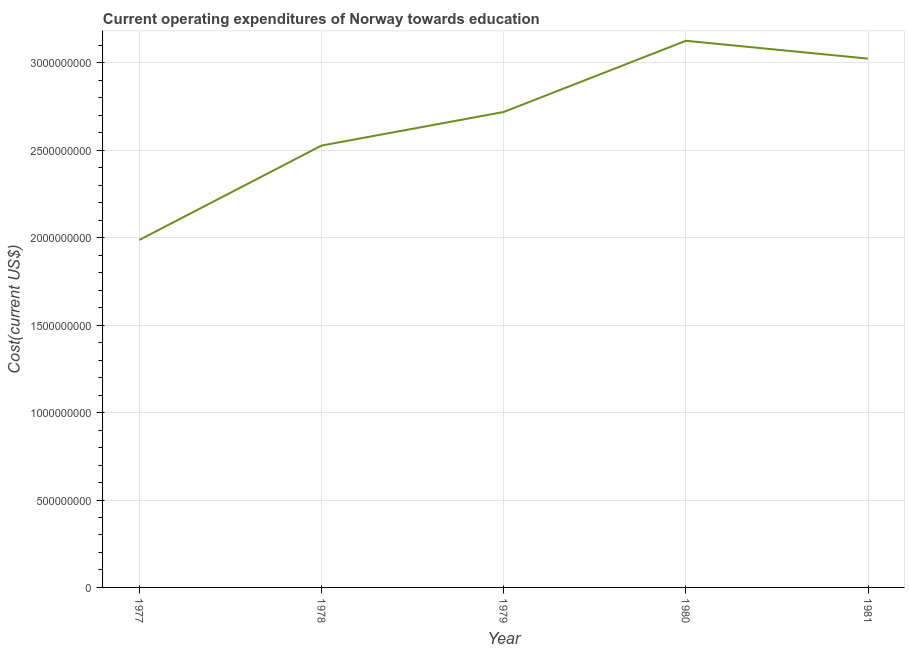What is the education expenditure in 1979?
Your response must be concise. 2.72e+09. Across all years, what is the maximum education expenditure?
Provide a short and direct response. 3.13e+09. Across all years, what is the minimum education expenditure?
Keep it short and to the point. 1.99e+09. In which year was the education expenditure minimum?
Give a very brief answer. 1977. What is the sum of the education expenditure?
Make the answer very short. 1.34e+1. What is the difference between the education expenditure in 1978 and 1979?
Ensure brevity in your answer.  -1.92e+08. What is the average education expenditure per year?
Make the answer very short. 2.68e+09. What is the median education expenditure?
Your answer should be compact. 2.72e+09. What is the ratio of the education expenditure in 1980 to that in 1981?
Provide a short and direct response. 1.03. Is the difference between the education expenditure in 1977 and 1981 greater than the difference between any two years?
Ensure brevity in your answer.  No. What is the difference between the highest and the second highest education expenditure?
Your answer should be very brief. 1.02e+08. What is the difference between the highest and the lowest education expenditure?
Offer a very short reply. 1.14e+09. In how many years, is the education expenditure greater than the average education expenditure taken over all years?
Provide a short and direct response. 3. What is the difference between two consecutive major ticks on the Y-axis?
Your answer should be compact. 5.00e+08. Are the values on the major ticks of Y-axis written in scientific E-notation?
Your answer should be very brief. No. What is the title of the graph?
Your answer should be very brief. Current operating expenditures of Norway towards education. What is the label or title of the X-axis?
Your answer should be very brief. Year. What is the label or title of the Y-axis?
Your answer should be compact. Cost(current US$). What is the Cost(current US$) of 1977?
Your answer should be very brief. 1.99e+09. What is the Cost(current US$) in 1978?
Keep it short and to the point. 2.53e+09. What is the Cost(current US$) of 1979?
Your answer should be very brief. 2.72e+09. What is the Cost(current US$) in 1980?
Ensure brevity in your answer.  3.13e+09. What is the Cost(current US$) in 1981?
Give a very brief answer. 3.02e+09. What is the difference between the Cost(current US$) in 1977 and 1978?
Your answer should be compact. -5.40e+08. What is the difference between the Cost(current US$) in 1977 and 1979?
Ensure brevity in your answer.  -7.32e+08. What is the difference between the Cost(current US$) in 1977 and 1980?
Your response must be concise. -1.14e+09. What is the difference between the Cost(current US$) in 1977 and 1981?
Offer a very short reply. -1.04e+09. What is the difference between the Cost(current US$) in 1978 and 1979?
Provide a short and direct response. -1.92e+08. What is the difference between the Cost(current US$) in 1978 and 1980?
Your answer should be very brief. -5.99e+08. What is the difference between the Cost(current US$) in 1978 and 1981?
Provide a succinct answer. -4.97e+08. What is the difference between the Cost(current US$) in 1979 and 1980?
Make the answer very short. -4.07e+08. What is the difference between the Cost(current US$) in 1979 and 1981?
Ensure brevity in your answer.  -3.05e+08. What is the difference between the Cost(current US$) in 1980 and 1981?
Your response must be concise. 1.02e+08. What is the ratio of the Cost(current US$) in 1977 to that in 1978?
Keep it short and to the point. 0.79. What is the ratio of the Cost(current US$) in 1977 to that in 1979?
Provide a short and direct response. 0.73. What is the ratio of the Cost(current US$) in 1977 to that in 1980?
Provide a succinct answer. 0.64. What is the ratio of the Cost(current US$) in 1977 to that in 1981?
Provide a short and direct response. 0.66. What is the ratio of the Cost(current US$) in 1978 to that in 1979?
Your answer should be very brief. 0.93. What is the ratio of the Cost(current US$) in 1978 to that in 1980?
Keep it short and to the point. 0.81. What is the ratio of the Cost(current US$) in 1978 to that in 1981?
Ensure brevity in your answer.  0.84. What is the ratio of the Cost(current US$) in 1979 to that in 1980?
Your response must be concise. 0.87. What is the ratio of the Cost(current US$) in 1979 to that in 1981?
Your response must be concise. 0.9. What is the ratio of the Cost(current US$) in 1980 to that in 1981?
Provide a short and direct response. 1.03. 